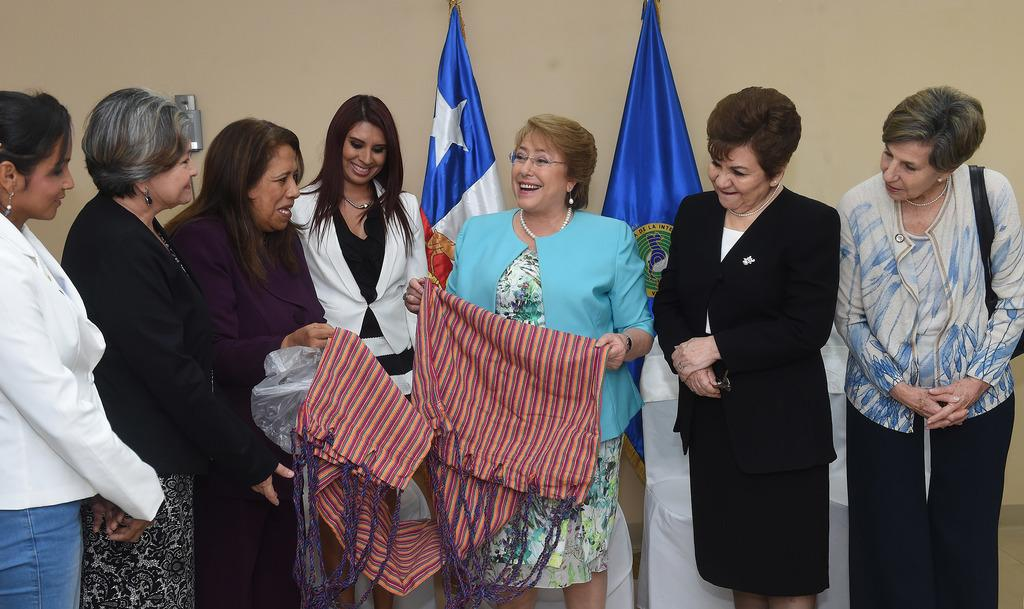Who or what can be seen in the image? There are people in the image. What are some of the people holding? Some people are holding clothes and covers. What can be seen in the background of the image? There are flags and objects visible in the background. What type of structure is present in the background? There is a wall in the background of the image. How many ears can be seen on the people in the image? There is no information about the number of ears visible on the people in the image. What color are the toes of the people in the image? There is no information about the color of the toes of the people in the image. 